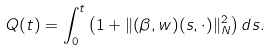<formula> <loc_0><loc_0><loc_500><loc_500>Q ( t ) = \int _ { 0 } ^ { t } \left ( 1 + \| ( \beta , w ) ( s , \cdot ) \| _ { N } ^ { 2 } \right ) d s .</formula> 